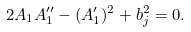Convert formula to latex. <formula><loc_0><loc_0><loc_500><loc_500>2 A _ { 1 } A _ { 1 } ^ { \prime \prime } - ( A _ { 1 } ^ { \prime } ) ^ { 2 } + b _ { j } ^ { 2 } = 0 .</formula> 